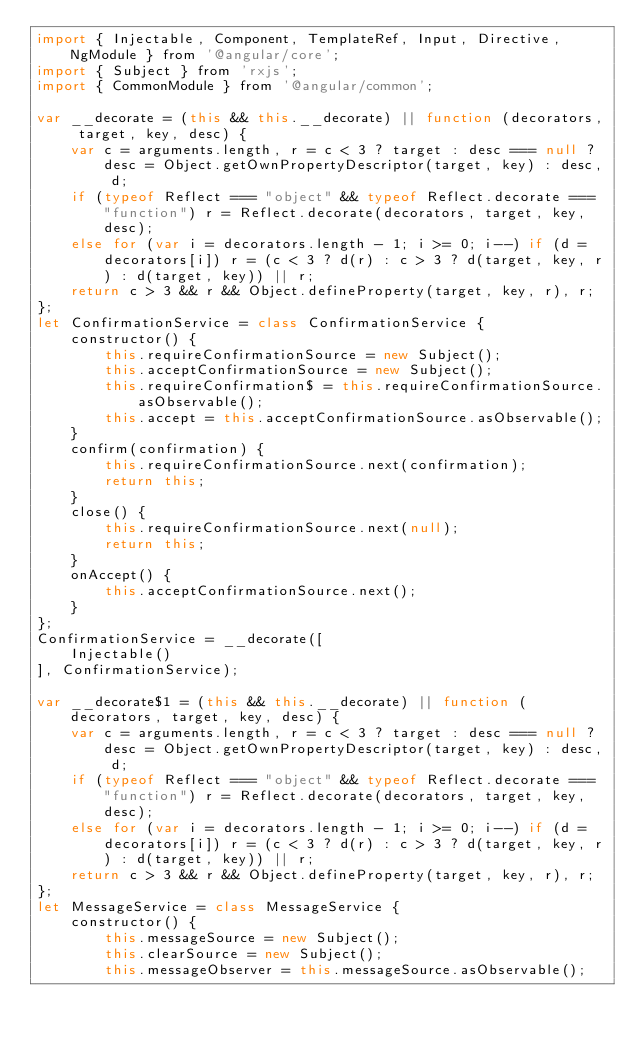Convert code to text. <code><loc_0><loc_0><loc_500><loc_500><_JavaScript_>import { Injectable, Component, TemplateRef, Input, Directive, NgModule } from '@angular/core';
import { Subject } from 'rxjs';
import { CommonModule } from '@angular/common';

var __decorate = (this && this.__decorate) || function (decorators, target, key, desc) {
    var c = arguments.length, r = c < 3 ? target : desc === null ? desc = Object.getOwnPropertyDescriptor(target, key) : desc, d;
    if (typeof Reflect === "object" && typeof Reflect.decorate === "function") r = Reflect.decorate(decorators, target, key, desc);
    else for (var i = decorators.length - 1; i >= 0; i--) if (d = decorators[i]) r = (c < 3 ? d(r) : c > 3 ? d(target, key, r) : d(target, key)) || r;
    return c > 3 && r && Object.defineProperty(target, key, r), r;
};
let ConfirmationService = class ConfirmationService {
    constructor() {
        this.requireConfirmationSource = new Subject();
        this.acceptConfirmationSource = new Subject();
        this.requireConfirmation$ = this.requireConfirmationSource.asObservable();
        this.accept = this.acceptConfirmationSource.asObservable();
    }
    confirm(confirmation) {
        this.requireConfirmationSource.next(confirmation);
        return this;
    }
    close() {
        this.requireConfirmationSource.next(null);
        return this;
    }
    onAccept() {
        this.acceptConfirmationSource.next();
    }
};
ConfirmationService = __decorate([
    Injectable()
], ConfirmationService);

var __decorate$1 = (this && this.__decorate) || function (decorators, target, key, desc) {
    var c = arguments.length, r = c < 3 ? target : desc === null ? desc = Object.getOwnPropertyDescriptor(target, key) : desc, d;
    if (typeof Reflect === "object" && typeof Reflect.decorate === "function") r = Reflect.decorate(decorators, target, key, desc);
    else for (var i = decorators.length - 1; i >= 0; i--) if (d = decorators[i]) r = (c < 3 ? d(r) : c > 3 ? d(target, key, r) : d(target, key)) || r;
    return c > 3 && r && Object.defineProperty(target, key, r), r;
};
let MessageService = class MessageService {
    constructor() {
        this.messageSource = new Subject();
        this.clearSource = new Subject();
        this.messageObserver = this.messageSource.asObservable();</code> 